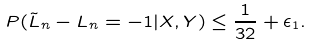<formula> <loc_0><loc_0><loc_500><loc_500>P ( \tilde { L } _ { n } - L _ { n } = - 1 | X , Y ) \leq \frac { 1 } { 3 2 } + \epsilon _ { 1 } .</formula> 